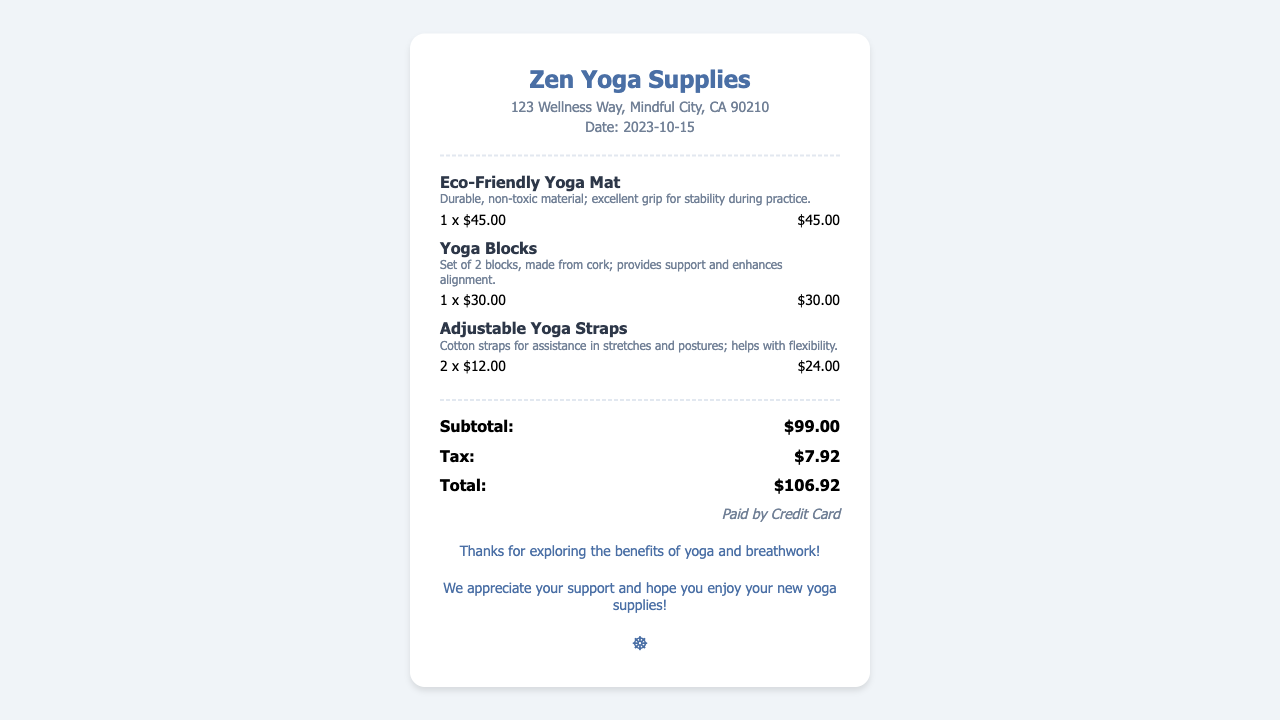What is the store name? The store name is the first element listed in the document, which identifies the business where the purchase was made.
Answer: Zen Yoga Supplies What is the date of purchase? The date of purchase is mentioned in the document under the header section and indicates when the transaction occurred.
Answer: 2023-10-15 What is the total cost of the yoga supplies? The total cost is highlighted at the bottom of the receipt and represents the final amount to be paid after tax.
Answer: $106.92 How many yoga straps were purchased? The quantity of yoga straps is specified in the item details and indicates how many were included in the purchase.
Answer: 2 What is the price of the yoga blocks? The price of the yoga blocks is mentioned in the item details and indicates the individual cost for the set purchased.
Answer: $30.00 What method of payment was used? The method of payment is stated at the end of the receipt and informs how the payment was made.
Answer: Credit Card What is the subtotal before tax? The subtotal is the total amount before tax is applied and is listed separately in the total section.
Answer: $99.00 What is the description of the eco-friendly yoga mat? The description for the yoga mat provides details on its features and material and is included with the item information.
Answer: Durable, non-toxic material; excellent grip for stability during practice What does the customer note suggest? The customer note gives appreciation for the purchase and hints at the benefits of yoga and breathwork, conveying encouragement.
Answer: Thanks for exploring the benefits of yoga and breathwork! 